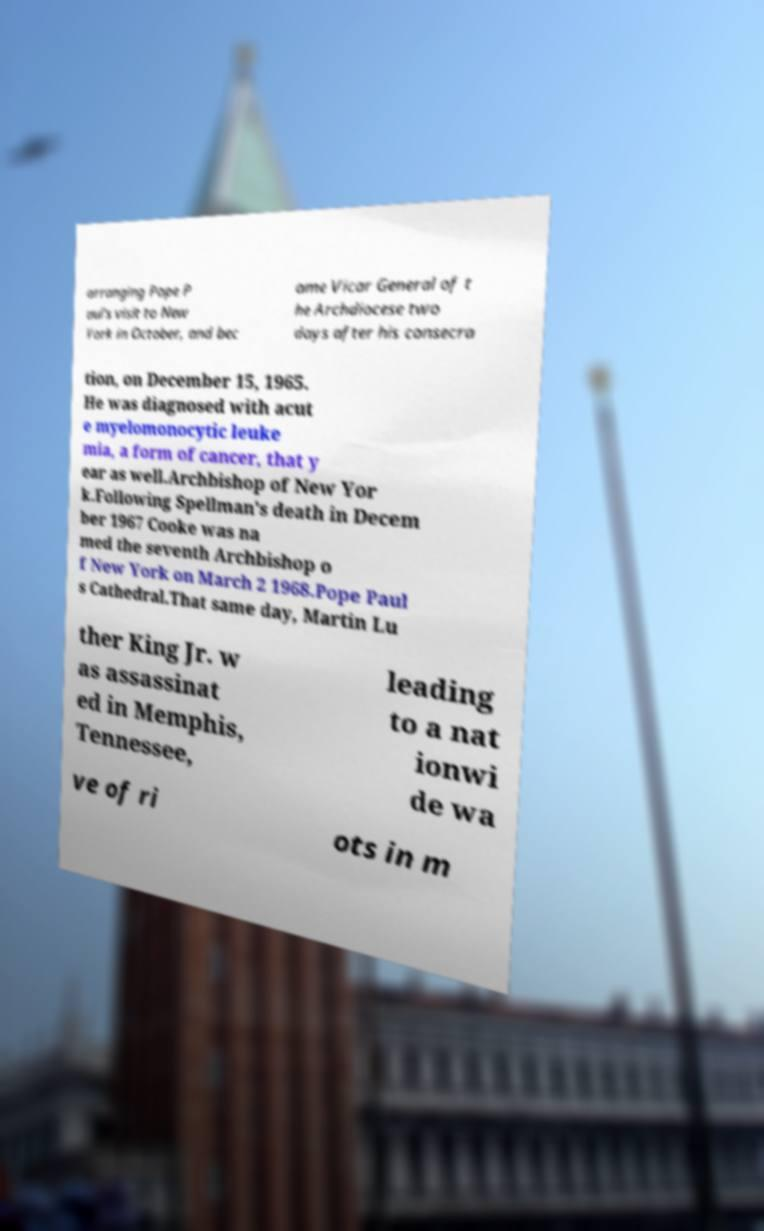I need the written content from this picture converted into text. Can you do that? arranging Pope P aul's visit to New York in October, and bec ame Vicar General of t he Archdiocese two days after his consecra tion, on December 15, 1965. He was diagnosed with acut e myelomonocytic leuke mia, a form of cancer, that y ear as well.Archbishop of New Yor k.Following Spellman's death in Decem ber 1967 Cooke was na med the seventh Archbishop o f New York on March 2 1968.Pope Paul s Cathedral.That same day, Martin Lu ther King Jr. w as assassinat ed in Memphis, Tennessee, leading to a nat ionwi de wa ve of ri ots in m 